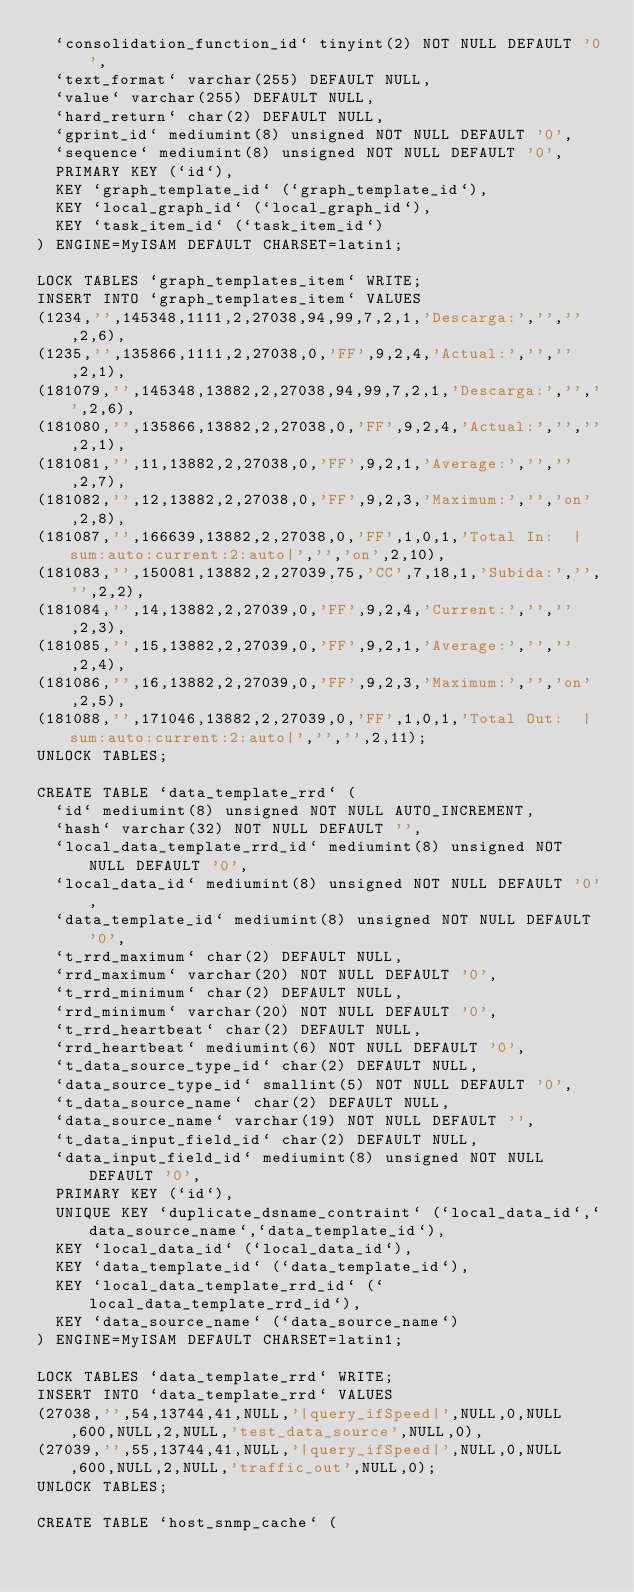<code> <loc_0><loc_0><loc_500><loc_500><_SQL_>  `consolidation_function_id` tinyint(2) NOT NULL DEFAULT '0',
  `text_format` varchar(255) DEFAULT NULL,
  `value` varchar(255) DEFAULT NULL,
  `hard_return` char(2) DEFAULT NULL,
  `gprint_id` mediumint(8) unsigned NOT NULL DEFAULT '0',
  `sequence` mediumint(8) unsigned NOT NULL DEFAULT '0',
  PRIMARY KEY (`id`),
  KEY `graph_template_id` (`graph_template_id`),
  KEY `local_graph_id` (`local_graph_id`),
  KEY `task_item_id` (`task_item_id`)
) ENGINE=MyISAM DEFAULT CHARSET=latin1;

LOCK TABLES `graph_templates_item` WRITE;
INSERT INTO `graph_templates_item` VALUES
(1234,'',145348,1111,2,27038,94,99,7,2,1,'Descarga:','','',2,6),
(1235,'',135866,1111,2,27038,0,'FF',9,2,4,'Actual:','','',2,1),
(181079,'',145348,13882,2,27038,94,99,7,2,1,'Descarga:','','',2,6),
(181080,'',135866,13882,2,27038,0,'FF',9,2,4,'Actual:','','',2,1),
(181081,'',11,13882,2,27038,0,'FF',9,2,1,'Average:','','',2,7),
(181082,'',12,13882,2,27038,0,'FF',9,2,3,'Maximum:','','on',2,8),
(181087,'',166639,13882,2,27038,0,'FF',1,0,1,'Total In:  |sum:auto:current:2:auto|','','on',2,10),
(181083,'',150081,13882,2,27039,75,'CC',7,18,1,'Subida:','','',2,2),
(181084,'',14,13882,2,27039,0,'FF',9,2,4,'Current:','','',2,3),
(181085,'',15,13882,2,27039,0,'FF',9,2,1,'Average:','','',2,4),
(181086,'',16,13882,2,27039,0,'FF',9,2,3,'Maximum:','','on',2,5),
(181088,'',171046,13882,2,27039,0,'FF',1,0,1,'Total Out:  |sum:auto:current:2:auto|','','',2,11);
UNLOCK TABLES;

CREATE TABLE `data_template_rrd` (
  `id` mediumint(8) unsigned NOT NULL AUTO_INCREMENT,
  `hash` varchar(32) NOT NULL DEFAULT '',
  `local_data_template_rrd_id` mediumint(8) unsigned NOT NULL DEFAULT '0',
  `local_data_id` mediumint(8) unsigned NOT NULL DEFAULT '0',
  `data_template_id` mediumint(8) unsigned NOT NULL DEFAULT '0',
  `t_rrd_maximum` char(2) DEFAULT NULL,
  `rrd_maximum` varchar(20) NOT NULL DEFAULT '0',
  `t_rrd_minimum` char(2) DEFAULT NULL,
  `rrd_minimum` varchar(20) NOT NULL DEFAULT '0',
  `t_rrd_heartbeat` char(2) DEFAULT NULL,
  `rrd_heartbeat` mediumint(6) NOT NULL DEFAULT '0',
  `t_data_source_type_id` char(2) DEFAULT NULL,
  `data_source_type_id` smallint(5) NOT NULL DEFAULT '0',
  `t_data_source_name` char(2) DEFAULT NULL,
  `data_source_name` varchar(19) NOT NULL DEFAULT '',
  `t_data_input_field_id` char(2) DEFAULT NULL,
  `data_input_field_id` mediumint(8) unsigned NOT NULL DEFAULT '0',
  PRIMARY KEY (`id`),
  UNIQUE KEY `duplicate_dsname_contraint` (`local_data_id`,`data_source_name`,`data_template_id`),
  KEY `local_data_id` (`local_data_id`),
  KEY `data_template_id` (`data_template_id`),
  KEY `local_data_template_rrd_id` (`local_data_template_rrd_id`),
  KEY `data_source_name` (`data_source_name`)
) ENGINE=MyISAM DEFAULT CHARSET=latin1;

LOCK TABLES `data_template_rrd` WRITE;
INSERT INTO `data_template_rrd` VALUES
(27038,'',54,13744,41,NULL,'|query_ifSpeed|',NULL,0,NULL,600,NULL,2,NULL,'test_data_source',NULL,0),
(27039,'',55,13744,41,NULL,'|query_ifSpeed|',NULL,0,NULL,600,NULL,2,NULL,'traffic_out',NULL,0);
UNLOCK TABLES;

CREATE TABLE `host_snmp_cache` (</code> 